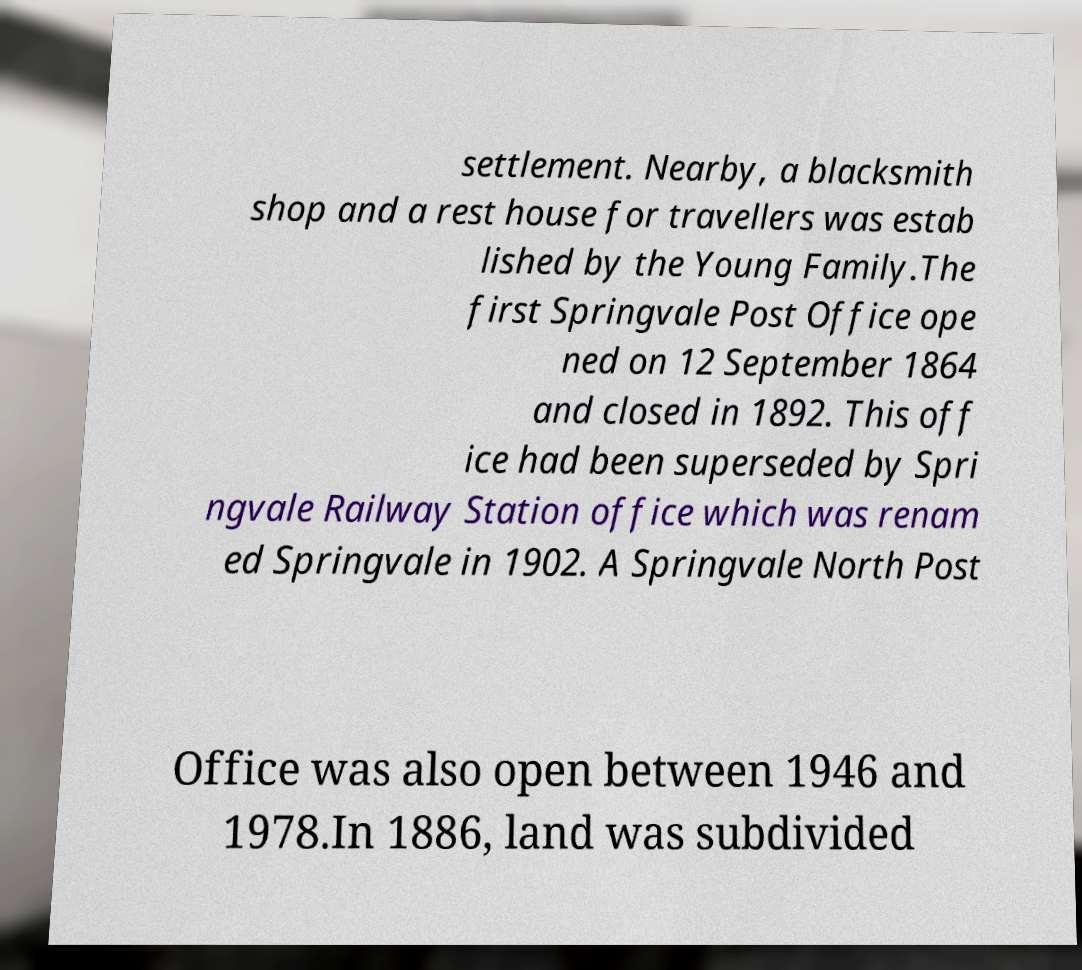For documentation purposes, I need the text within this image transcribed. Could you provide that? settlement. Nearby, a blacksmith shop and a rest house for travellers was estab lished by the Young Family.The first Springvale Post Office ope ned on 12 September 1864 and closed in 1892. This off ice had been superseded by Spri ngvale Railway Station office which was renam ed Springvale in 1902. A Springvale North Post Office was also open between 1946 and 1978.In 1886, land was subdivided 